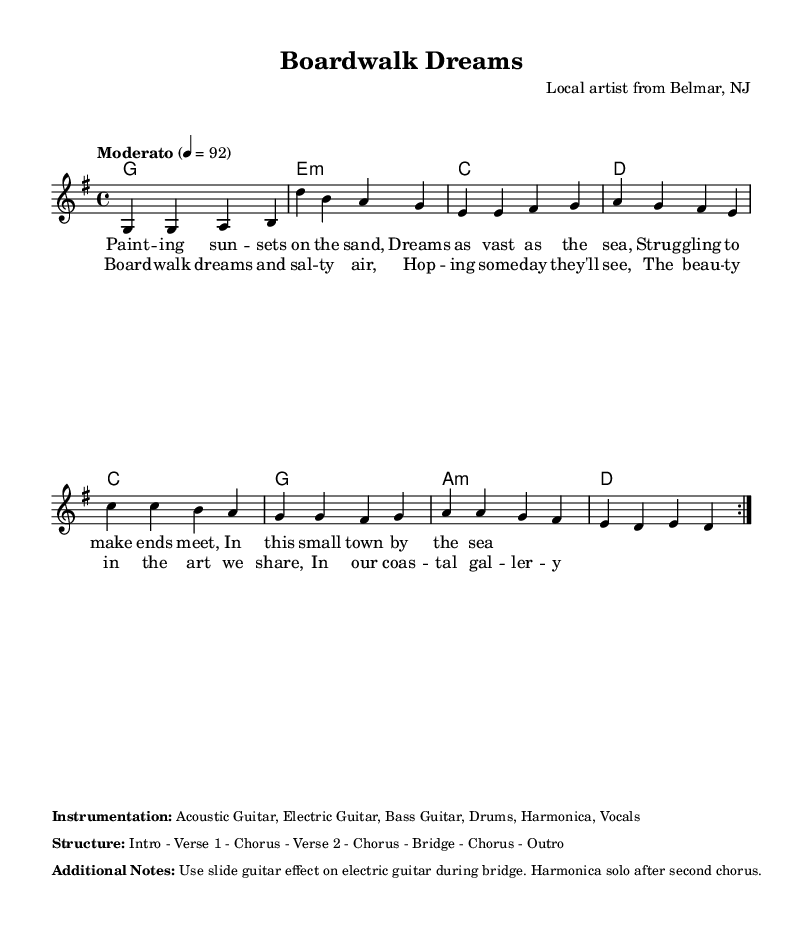What is the key signature of this music? The key signature is indicated at the beginning of the score, showing one sharp which is typical for G major.
Answer: G major What is the time signature of this music? The time signature is located at the beginning of the score in the form of a fraction, showing four beats in each measure. It specifies a common time feeling.
Answer: 4/4 What is the tempo marking of this music? The tempo marking is found in the global settings of the score, which indicates the speed at which the piece should be played, specifically setting the metronome marking at 92 beats per minute.
Answer: Moderato, 92 How many measures are in the chorus? The chorus section contains four lines of lyrics, each corresponding to a measure in the musical notation, thus resulting in a total of four measures for this section.
Answer: 4 measures What instruments are included in the instrumentation? The instruments are specifically listed in the score under the 'Instrumentation' section, detailing the types of guitars, bass, drums, harmonica, and vocals involved in the arrangement.
Answer: Acoustic Guitar, Electric Guitar, Bass Guitar, Drums, Harmonica, Vocals What is the structure of the song? The structure of the song is presented in the score under the 'Structure' section and outlines the order of sections in the piece, indicating a pattern that includes verses, choruses, and other musical components.
Answer: Intro - Verse 1 - Chorus - Verse 2 - Chorus - Bridge - Chorus - Outro 